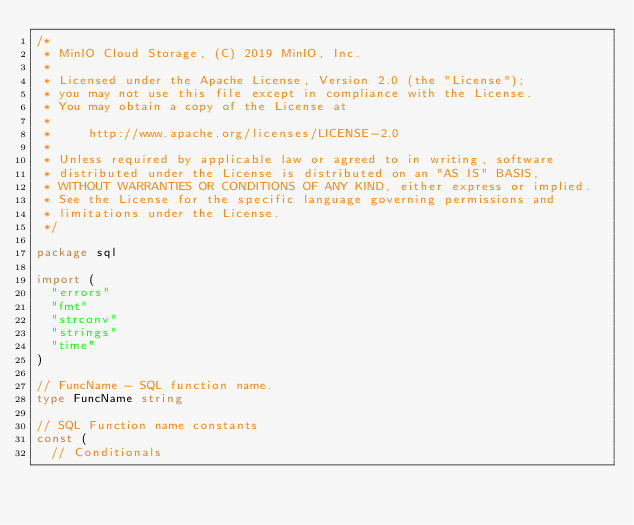<code> <loc_0><loc_0><loc_500><loc_500><_Go_>/*
 * MinIO Cloud Storage, (C) 2019 MinIO, Inc.
 *
 * Licensed under the Apache License, Version 2.0 (the "License");
 * you may not use this file except in compliance with the License.
 * You may obtain a copy of the License at
 *
 *     http://www.apache.org/licenses/LICENSE-2.0
 *
 * Unless required by applicable law or agreed to in writing, software
 * distributed under the License is distributed on an "AS IS" BASIS,
 * WITHOUT WARRANTIES OR CONDITIONS OF ANY KIND, either express or implied.
 * See the License for the specific language governing permissions and
 * limitations under the License.
 */

package sql

import (
	"errors"
	"fmt"
	"strconv"
	"strings"
	"time"
)

// FuncName - SQL function name.
type FuncName string

// SQL Function name constants
const (
	// Conditionals</code> 